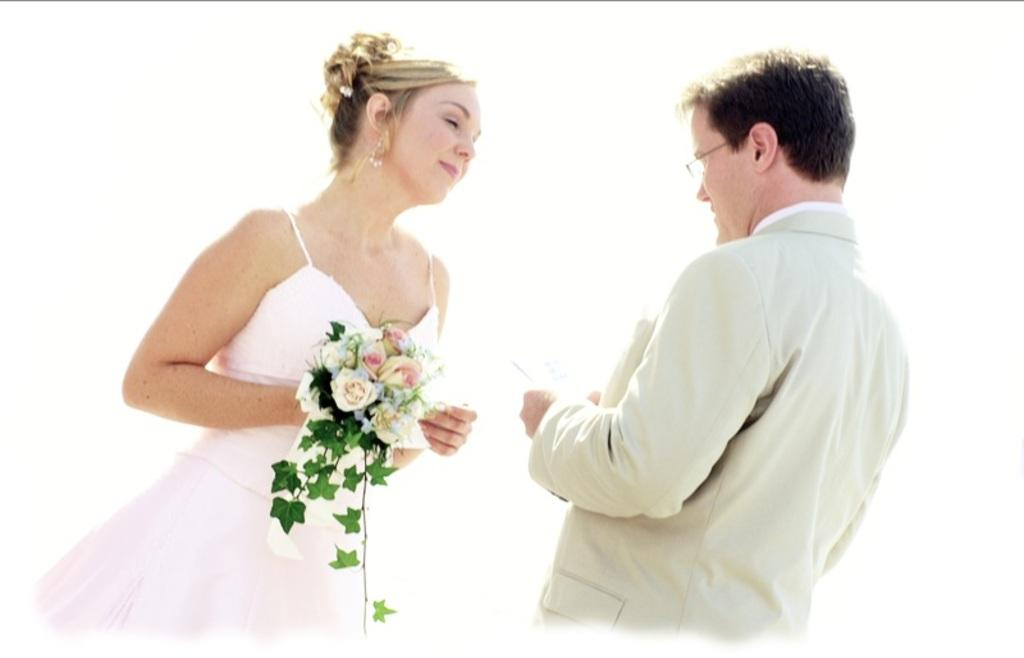What is the woman in the image holding? The woman is holding a bouquet. What can be seen on the man's face in the image? The man is wearing spectacles. What color is the dress worn by the woman in the image? The woman is wearing a white dress. What is the color of the background in the image? The background of the image is completely white. What is the condition of the railway in the image? There is no railway present in the image. What is the relationship between the woman and the man in the image? The provided facts do not mention the relationship between the woman and the man in the image. 